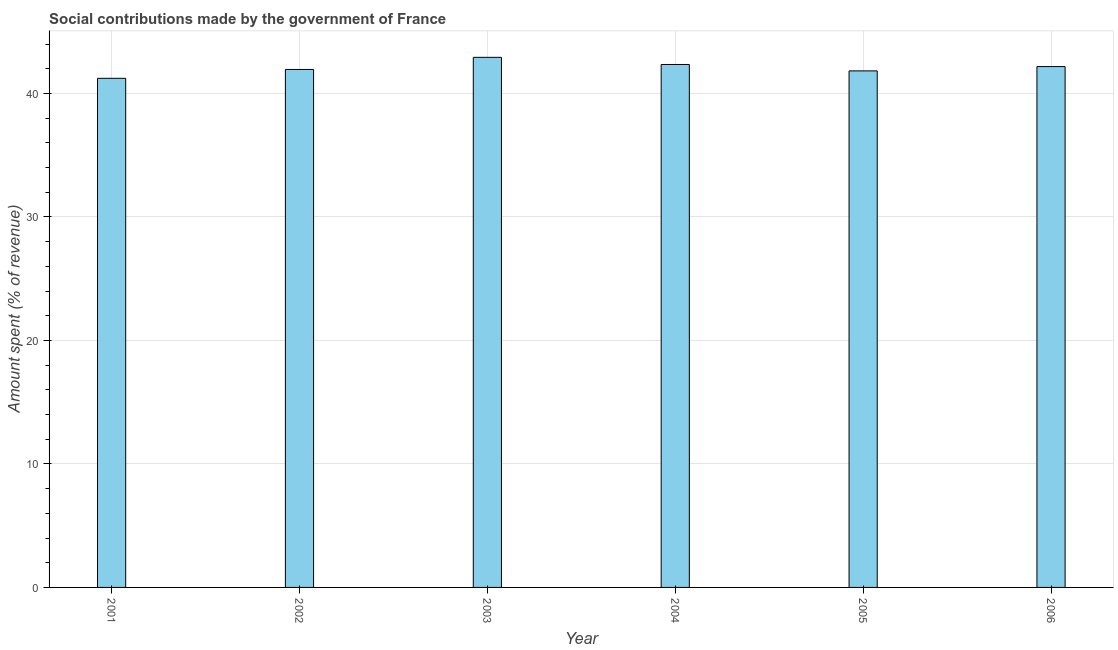Does the graph contain grids?
Ensure brevity in your answer.  Yes. What is the title of the graph?
Provide a short and direct response. Social contributions made by the government of France. What is the label or title of the X-axis?
Your answer should be very brief. Year. What is the label or title of the Y-axis?
Ensure brevity in your answer.  Amount spent (% of revenue). What is the amount spent in making social contributions in 2004?
Your response must be concise. 42.35. Across all years, what is the maximum amount spent in making social contributions?
Offer a terse response. 42.93. Across all years, what is the minimum amount spent in making social contributions?
Keep it short and to the point. 41.23. What is the sum of the amount spent in making social contributions?
Give a very brief answer. 252.48. What is the difference between the amount spent in making social contributions in 2001 and 2004?
Provide a succinct answer. -1.12. What is the average amount spent in making social contributions per year?
Your response must be concise. 42.08. What is the median amount spent in making social contributions?
Your answer should be very brief. 42.07. In how many years, is the amount spent in making social contributions greater than 4 %?
Keep it short and to the point. 6. Do a majority of the years between 2003 and 2006 (inclusive) have amount spent in making social contributions greater than 18 %?
Give a very brief answer. Yes. What is the difference between the highest and the second highest amount spent in making social contributions?
Keep it short and to the point. 0.58. What is the difference between the highest and the lowest amount spent in making social contributions?
Your answer should be compact. 1.7. In how many years, is the amount spent in making social contributions greater than the average amount spent in making social contributions taken over all years?
Provide a short and direct response. 3. How many years are there in the graph?
Offer a terse response. 6. Are the values on the major ticks of Y-axis written in scientific E-notation?
Keep it short and to the point. No. What is the Amount spent (% of revenue) of 2001?
Make the answer very short. 41.23. What is the Amount spent (% of revenue) of 2002?
Offer a terse response. 41.95. What is the Amount spent (% of revenue) of 2003?
Give a very brief answer. 42.93. What is the Amount spent (% of revenue) of 2004?
Your answer should be compact. 42.35. What is the Amount spent (% of revenue) in 2005?
Offer a terse response. 41.83. What is the Amount spent (% of revenue) in 2006?
Ensure brevity in your answer.  42.18. What is the difference between the Amount spent (% of revenue) in 2001 and 2002?
Offer a very short reply. -0.72. What is the difference between the Amount spent (% of revenue) in 2001 and 2003?
Make the answer very short. -1.7. What is the difference between the Amount spent (% of revenue) in 2001 and 2004?
Keep it short and to the point. -1.12. What is the difference between the Amount spent (% of revenue) in 2001 and 2005?
Your answer should be very brief. -0.6. What is the difference between the Amount spent (% of revenue) in 2001 and 2006?
Your response must be concise. -0.95. What is the difference between the Amount spent (% of revenue) in 2002 and 2003?
Make the answer very short. -0.98. What is the difference between the Amount spent (% of revenue) in 2002 and 2004?
Your response must be concise. -0.4. What is the difference between the Amount spent (% of revenue) in 2002 and 2005?
Offer a very short reply. 0.11. What is the difference between the Amount spent (% of revenue) in 2002 and 2006?
Your answer should be compact. -0.23. What is the difference between the Amount spent (% of revenue) in 2003 and 2004?
Your answer should be very brief. 0.58. What is the difference between the Amount spent (% of revenue) in 2003 and 2005?
Ensure brevity in your answer.  1.1. What is the difference between the Amount spent (% of revenue) in 2003 and 2006?
Give a very brief answer. 0.75. What is the difference between the Amount spent (% of revenue) in 2004 and 2005?
Give a very brief answer. 0.52. What is the difference between the Amount spent (% of revenue) in 2004 and 2006?
Give a very brief answer. 0.17. What is the difference between the Amount spent (% of revenue) in 2005 and 2006?
Provide a short and direct response. -0.35. What is the ratio of the Amount spent (% of revenue) in 2001 to that in 2002?
Make the answer very short. 0.98. What is the ratio of the Amount spent (% of revenue) in 2001 to that in 2005?
Your answer should be compact. 0.99. What is the ratio of the Amount spent (% of revenue) in 2002 to that in 2005?
Keep it short and to the point. 1. What is the ratio of the Amount spent (% of revenue) in 2002 to that in 2006?
Provide a succinct answer. 0.99. What is the ratio of the Amount spent (% of revenue) in 2005 to that in 2006?
Offer a terse response. 0.99. 